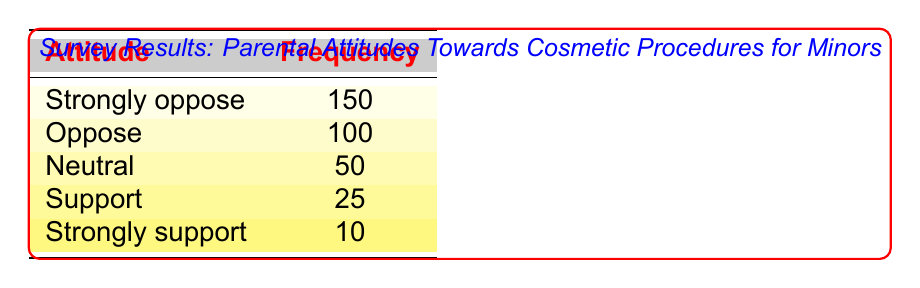What is the frequency of parents who are "Strongly oppose" to cosmetic procedures for minors? The table clearly shows that the frequency associated with the attitude "Strongly oppose" is 150.
Answer: 150 How many parents support cosmetic procedures for minors (both support and strongly support)? The frequencies for "Support" and "Strongly support" are 25 and 10, respectively. Adding these together gives 25 + 10 = 35.
Answer: 35 Is there a significant difference between the number of parents who "Oppose" and those who "Support"? The frequency for "Oppose" is 100, and for "Support", it's 25. The difference is 100 - 25 = 75, indicating a significant disparity.
Answer: Yes What percentage of parents are "Neutral" towards cosmetic procedures for minors? The frequency for "Neutral" is 50, and the total frequency is the sum of all attitudes: 150 + 100 + 50 + 25 + 10 = 335. The percentage is (50 / 335) * 100 ≈ 14.93%.
Answer: Approximately 14.93% How many more parents "Strongly oppose" than "Strongly support"? The frequency for "Strongly oppose" is 150, and for "Strongly support", it is 10. The difference is 150 - 10 = 140, indicating that many more parents strongly oppose than strongly support.
Answer: 140 Do more parents "Oppose" cosmetic procedures than are "Neutral"? The frequency for "Oppose" is 100, while for "Neutral", it is 50. Since 100 is greater than 50, more parents do indeed oppose than are neutral.
Answer: Yes What is the total frequency of parents who are either "Support" or "Strongly support"? The frequencies for "Support" and "Strongly support" are 25 and 10, respectively. The total is 25 + 10 = 35.
Answer: 35 If the frequencies for "Neutral", "Support", and "Strongly support" are combined, what is their total? The frequencies for these attitudes are 50 (Neutral), 25 (Support), and 10 (Strongly support). The total sum is 50 + 25 + 10 = 85.
Answer: 85 